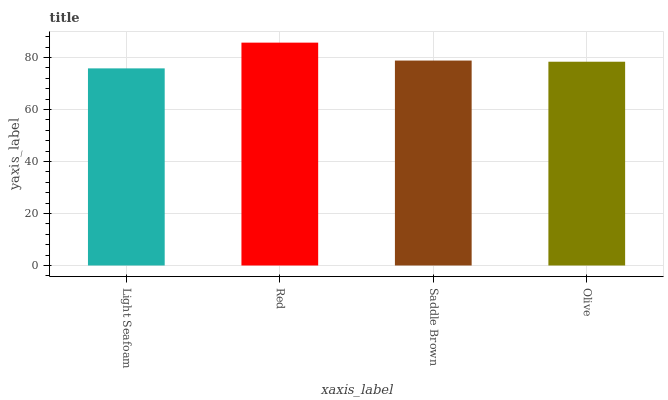Is Light Seafoam the minimum?
Answer yes or no. Yes. Is Red the maximum?
Answer yes or no. Yes. Is Saddle Brown the minimum?
Answer yes or no. No. Is Saddle Brown the maximum?
Answer yes or no. No. Is Red greater than Saddle Brown?
Answer yes or no. Yes. Is Saddle Brown less than Red?
Answer yes or no. Yes. Is Saddle Brown greater than Red?
Answer yes or no. No. Is Red less than Saddle Brown?
Answer yes or no. No. Is Saddle Brown the high median?
Answer yes or no. Yes. Is Olive the low median?
Answer yes or no. Yes. Is Olive the high median?
Answer yes or no. No. Is Red the low median?
Answer yes or no. No. 